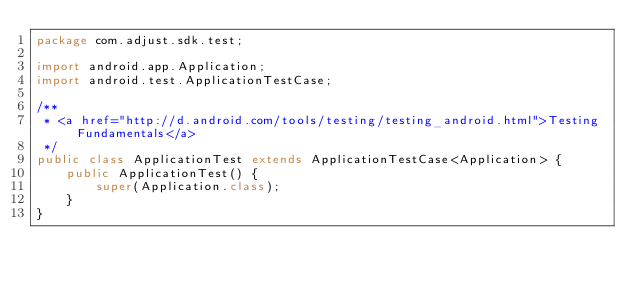<code> <loc_0><loc_0><loc_500><loc_500><_Java_>package com.adjust.sdk.test;

import android.app.Application;
import android.test.ApplicationTestCase;

/**
 * <a href="http://d.android.com/tools/testing/testing_android.html">Testing Fundamentals</a>
 */
public class ApplicationTest extends ApplicationTestCase<Application> {
    public ApplicationTest() {
        super(Application.class);
    }
}</code> 